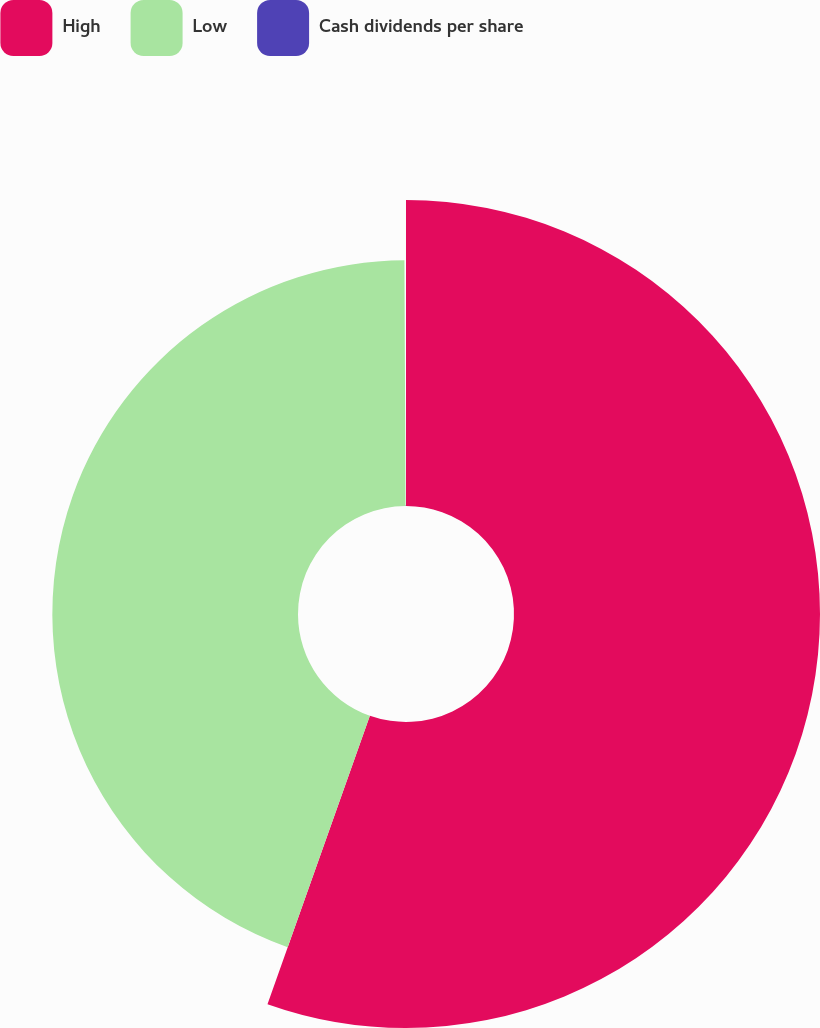Convert chart. <chart><loc_0><loc_0><loc_500><loc_500><pie_chart><fcel>High<fcel>Low<fcel>Cash dividends per share<nl><fcel>55.43%<fcel>44.5%<fcel>0.07%<nl></chart> 